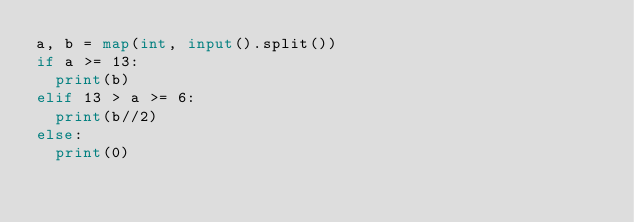<code> <loc_0><loc_0><loc_500><loc_500><_Python_>a, b = map(int, input().split())
if a >= 13:
  print(b)
elif 13 > a >= 6:
  print(b//2)
else:
  print(0)</code> 